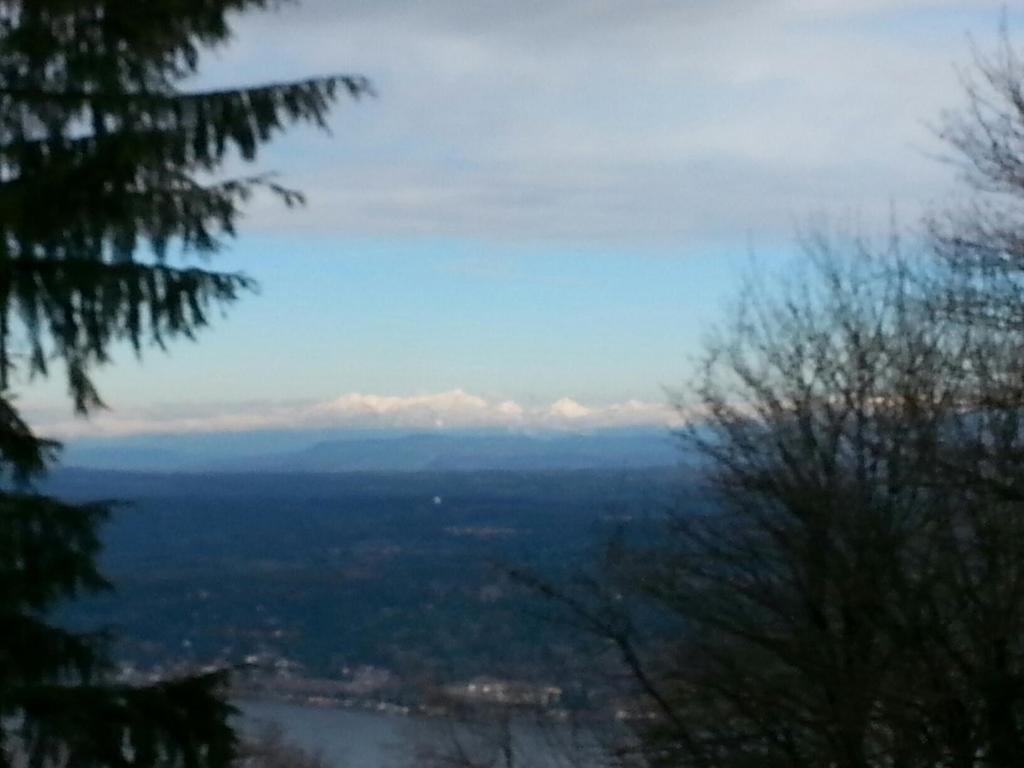Please provide a concise description of this image. In the image there are trees on either side and in the front the land is totally covered with plants and trees all over it and above its sky with clouds. 